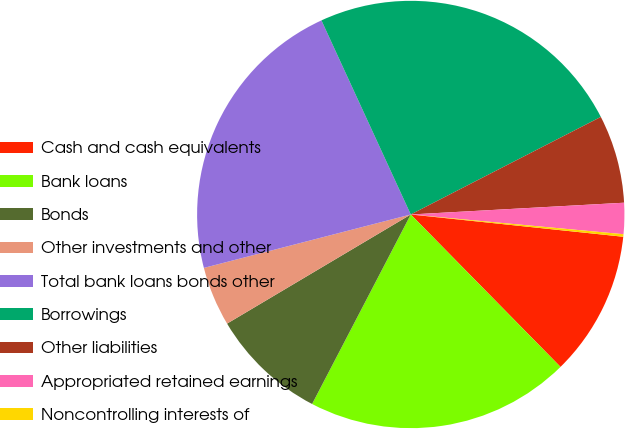<chart> <loc_0><loc_0><loc_500><loc_500><pie_chart><fcel>Cash and cash equivalents<fcel>Bank loans<fcel>Bonds<fcel>Other investments and other<fcel>Total bank loans bonds other<fcel>Borrowings<fcel>Other liabilities<fcel>Appropriated retained earnings<fcel>Noncontrolling interests of<nl><fcel>10.98%<fcel>20.0%<fcel>8.83%<fcel>4.51%<fcel>22.16%<fcel>24.32%<fcel>6.67%<fcel>2.35%<fcel>0.19%<nl></chart> 